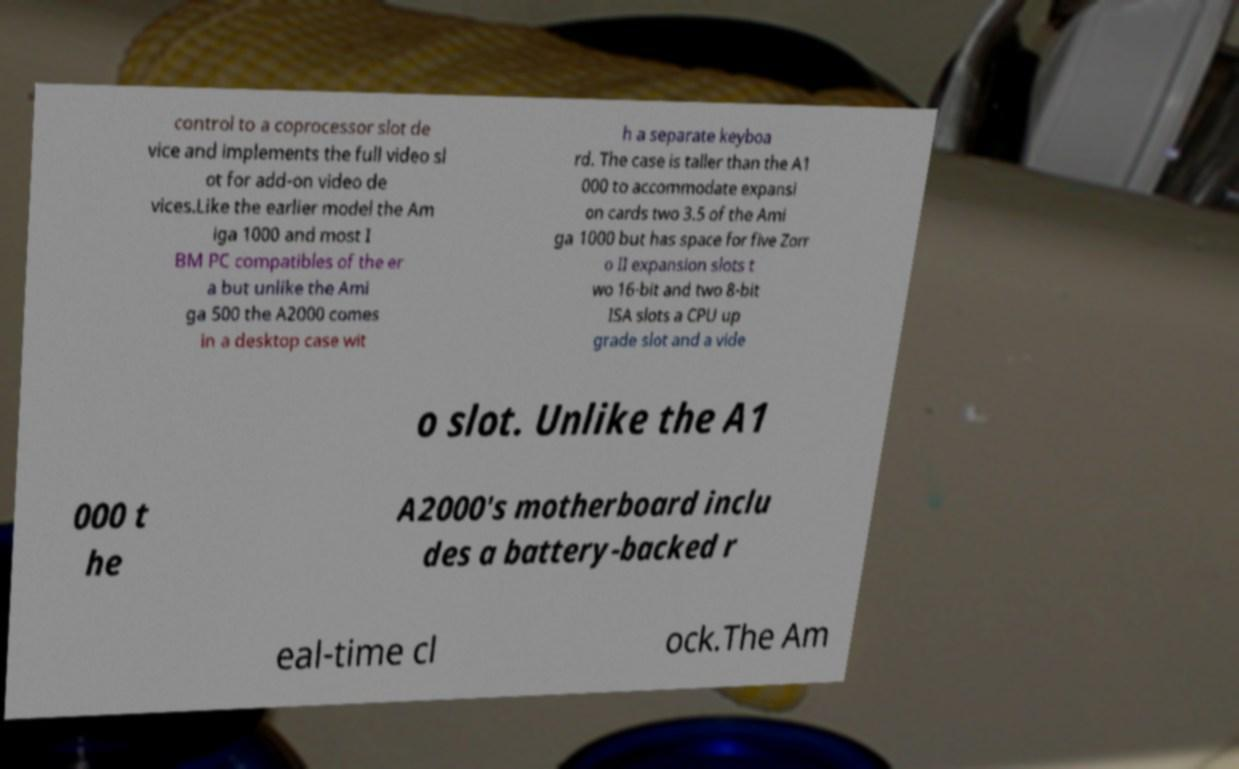Please read and relay the text visible in this image. What does it say? control to a coprocessor slot de vice and implements the full video sl ot for add-on video de vices.Like the earlier model the Am iga 1000 and most I BM PC compatibles of the er a but unlike the Ami ga 500 the A2000 comes in a desktop case wit h a separate keyboa rd. The case is taller than the A1 000 to accommodate expansi on cards two 3.5 of the Ami ga 1000 but has space for five Zorr o II expansion slots t wo 16-bit and two 8-bit ISA slots a CPU up grade slot and a vide o slot. Unlike the A1 000 t he A2000's motherboard inclu des a battery-backed r eal-time cl ock.The Am 